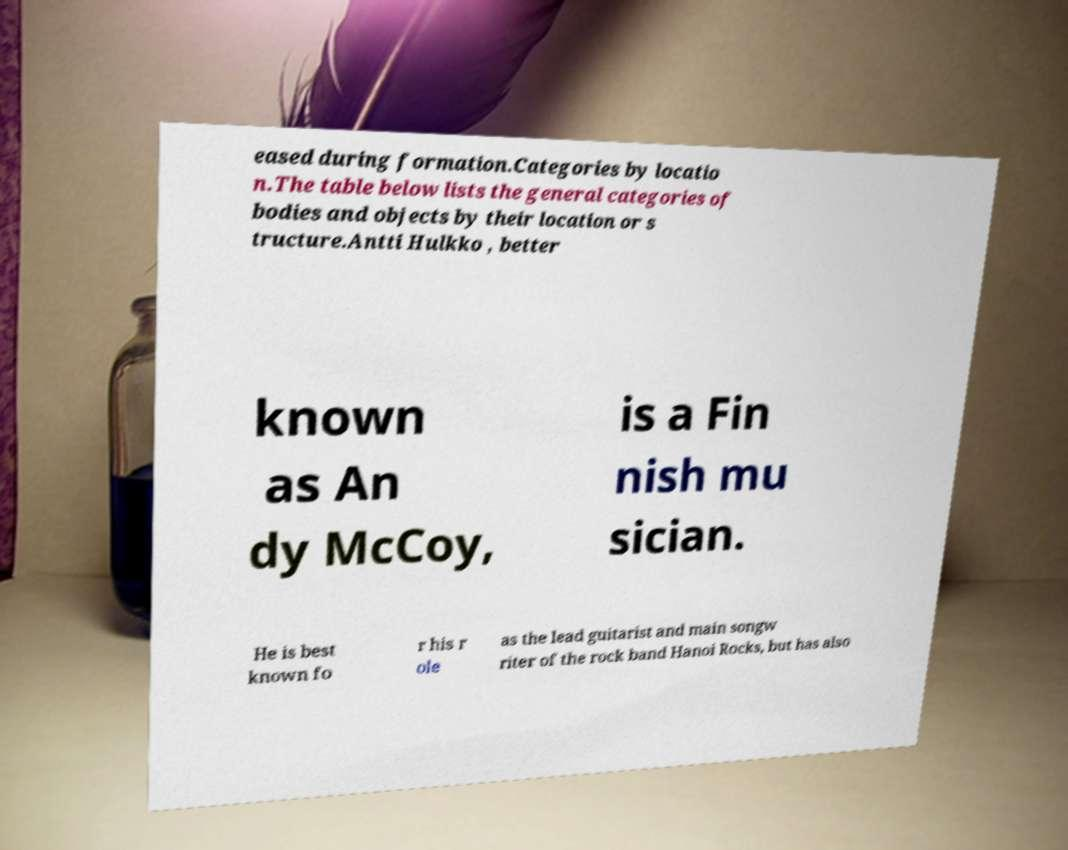Can you read and provide the text displayed in the image?This photo seems to have some interesting text. Can you extract and type it out for me? eased during formation.Categories by locatio n.The table below lists the general categories of bodies and objects by their location or s tructure.Antti Hulkko , better known as An dy McCoy, is a Fin nish mu sician. He is best known fo r his r ole as the lead guitarist and main songw riter of the rock band Hanoi Rocks, but has also 